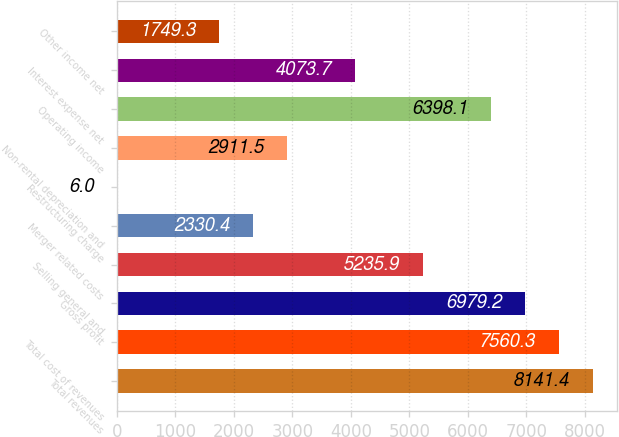Convert chart to OTSL. <chart><loc_0><loc_0><loc_500><loc_500><bar_chart><fcel>Total revenues<fcel>Total cost of revenues<fcel>Gross profit<fcel>Selling general and<fcel>Merger related costs<fcel>Restructuring charge<fcel>Non-rental depreciation and<fcel>Operating income<fcel>Interest expense net<fcel>Other income net<nl><fcel>8141.4<fcel>7560.3<fcel>6979.2<fcel>5235.9<fcel>2330.4<fcel>6<fcel>2911.5<fcel>6398.1<fcel>4073.7<fcel>1749.3<nl></chart> 